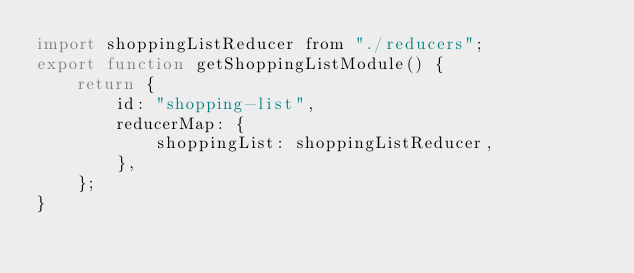<code> <loc_0><loc_0><loc_500><loc_500><_JavaScript_>import shoppingListReducer from "./reducers";
export function getShoppingListModule() {
    return {
        id: "shopping-list",
        reducerMap: {
            shoppingList: shoppingListReducer,
        },
    };
}
</code> 